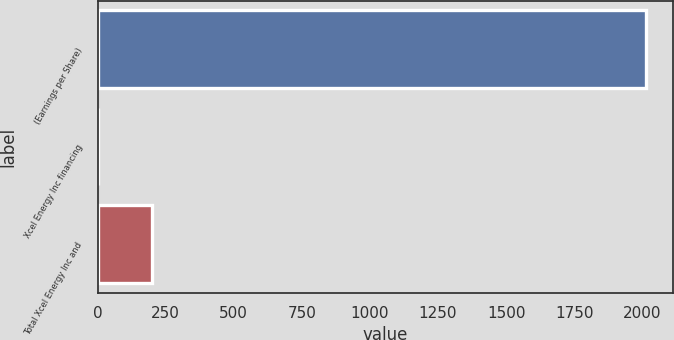Convert chart to OTSL. <chart><loc_0><loc_0><loc_500><loc_500><bar_chart><fcel>(Earnings per Share)<fcel>Xcel Energy Inc financing<fcel>Total Xcel Energy Inc and<nl><fcel>2013<fcel>0.13<fcel>201.42<nl></chart> 